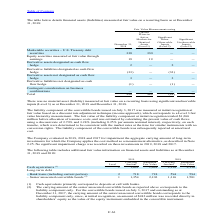According to Stmicroelectronics's financial document, What is the correspond of Cash equivalents? Cash equivalents primarily correspond to deposits at call with banks.. The document states: "(1) Cash equivalents primarily correspond to deposits at call with banks...." Also, Under which head of balance sheet does senior unsecured convertible bonds correspond to? The carrying amount of the senior unsecured convertible bonds as reported above corresponds to the liability component only.. The document states: "(2) The carrying amount of the senior unsecured convertible bonds as reported above corresponds to the liability component only. For the convertible b..." Also, How much amount was recorded in shareholders’ equity as the value of the equity instrument embedded in the convertible instrument? According to the financial document, $242 million. The relevant text states: "only, since, at initial recognition, an amount of $242 million was recorded directly in shareholders’ equity as the value of the equity instrument embedded in the..." Also, can you calculate: What is the increase/ (decrease) in Cash equivalents of Carrying Amount from 2018 to 2019? Based on the calculation: 1,691-2,138, the result is -447 (in millions). This is based on the information: "Cash equivalents (1) 1 1,691 1,691 2,138 2,138 Cash equivalents (1) 1 1,691 1,691 2,138 2,138..." The key data points involved are: 1,691, 2,138. Also, can you calculate: What is the increase/ (decrease) in Bank loans (including current portion) of Carrying Amount from 2018 to 2019? Based on the calculation: 718-594, the result is 124 (in millions). This is based on the information: "Bank loans (including current portion) 2 718 718 594 594 – Bank loans (including current portion) 2 718 718 594 594..." The key data points involved are: 594, 718. Also, can you calculate: What is the increase/ (decrease) in Senior unsecured convertible bonds of Carrying Amount from 2018 to 2019? Based on the calculation: 1,354-1,316, the result is 38 (in millions). This is based on the information: "ior unsecured convertible bonds (2) 1 1,354 2,103 1,316 1,501 – Senior unsecured convertible bonds (2) 1 1,354 2,103 1,316 1,501..." The key data points involved are: 1,316, 1,354. 